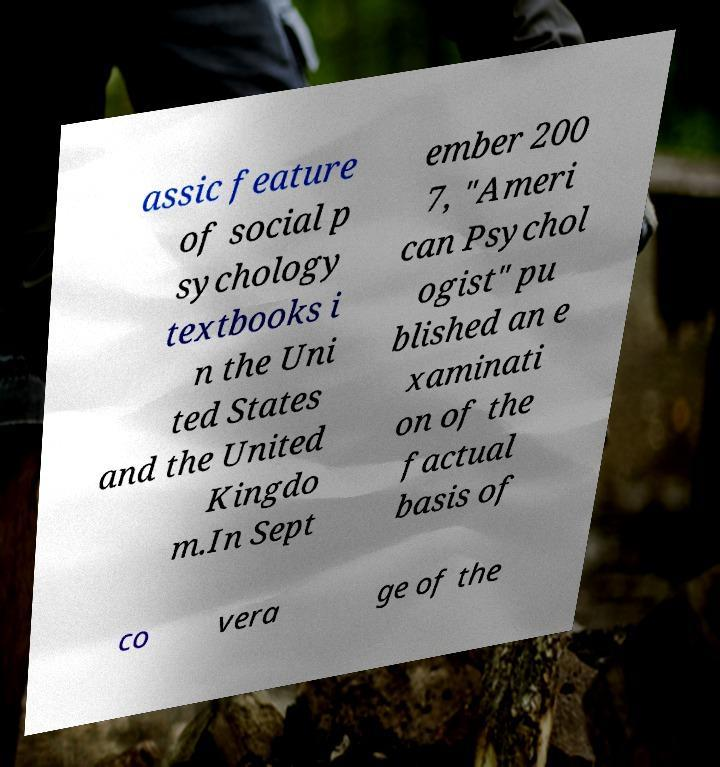Can you read and provide the text displayed in the image?This photo seems to have some interesting text. Can you extract and type it out for me? assic feature of social p sychology textbooks i n the Uni ted States and the United Kingdo m.In Sept ember 200 7, "Ameri can Psychol ogist" pu blished an e xaminati on of the factual basis of co vera ge of the 